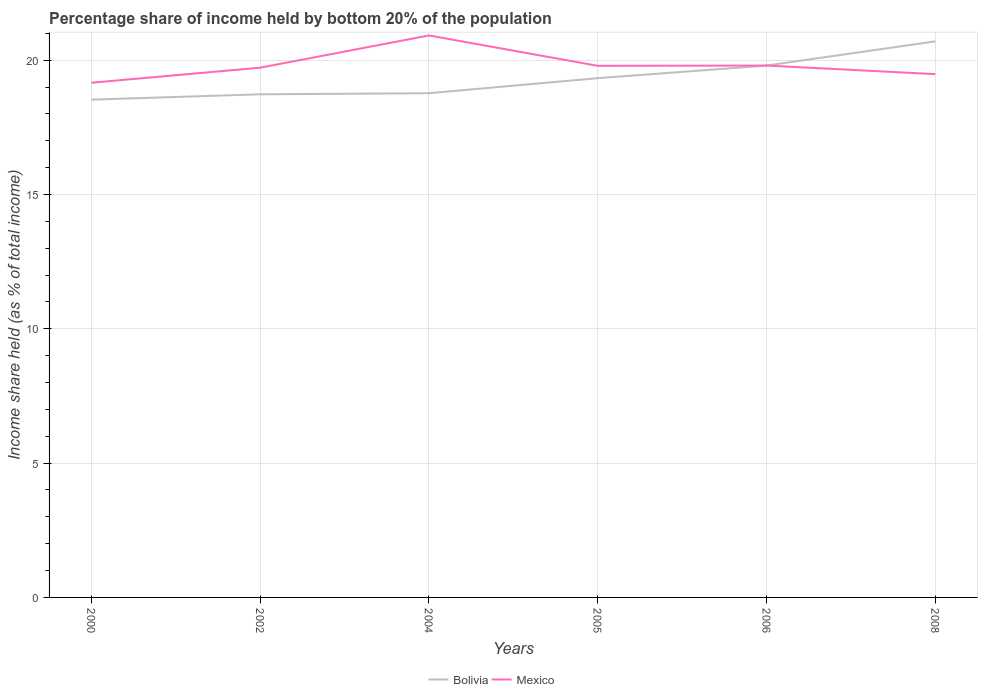Does the line corresponding to Mexico intersect with the line corresponding to Bolivia?
Ensure brevity in your answer.  Yes. Across all years, what is the maximum share of income held by bottom 20% of the population in Mexico?
Your response must be concise. 19.16. In which year was the share of income held by bottom 20% of the population in Bolivia maximum?
Your answer should be compact. 2000. What is the total share of income held by bottom 20% of the population in Mexico in the graph?
Give a very brief answer. -1.76. What is the difference between the highest and the second highest share of income held by bottom 20% of the population in Bolivia?
Offer a very short reply. 2.17. What is the difference between the highest and the lowest share of income held by bottom 20% of the population in Bolivia?
Provide a short and direct response. 3. How many years are there in the graph?
Make the answer very short. 6. What is the difference between two consecutive major ticks on the Y-axis?
Your answer should be very brief. 5. Does the graph contain any zero values?
Provide a succinct answer. No. How are the legend labels stacked?
Your answer should be very brief. Horizontal. What is the title of the graph?
Your answer should be compact. Percentage share of income held by bottom 20% of the population. What is the label or title of the X-axis?
Your answer should be very brief. Years. What is the label or title of the Y-axis?
Your answer should be very brief. Income share held (as % of total income). What is the Income share held (as % of total income) of Bolivia in 2000?
Make the answer very short. 18.53. What is the Income share held (as % of total income) of Mexico in 2000?
Give a very brief answer. 19.16. What is the Income share held (as % of total income) of Bolivia in 2002?
Provide a short and direct response. 18.73. What is the Income share held (as % of total income) in Mexico in 2002?
Ensure brevity in your answer.  19.72. What is the Income share held (as % of total income) of Bolivia in 2004?
Your answer should be very brief. 18.77. What is the Income share held (as % of total income) in Mexico in 2004?
Give a very brief answer. 20.92. What is the Income share held (as % of total income) in Bolivia in 2005?
Your answer should be very brief. 19.33. What is the Income share held (as % of total income) in Mexico in 2005?
Ensure brevity in your answer.  19.79. What is the Income share held (as % of total income) in Bolivia in 2006?
Your answer should be compact. 19.8. What is the Income share held (as % of total income) of Mexico in 2006?
Keep it short and to the point. 19.8. What is the Income share held (as % of total income) of Bolivia in 2008?
Provide a succinct answer. 20.7. What is the Income share held (as % of total income) in Mexico in 2008?
Your answer should be compact. 19.48. Across all years, what is the maximum Income share held (as % of total income) in Bolivia?
Offer a very short reply. 20.7. Across all years, what is the maximum Income share held (as % of total income) of Mexico?
Keep it short and to the point. 20.92. Across all years, what is the minimum Income share held (as % of total income) of Bolivia?
Provide a short and direct response. 18.53. Across all years, what is the minimum Income share held (as % of total income) of Mexico?
Your response must be concise. 19.16. What is the total Income share held (as % of total income) of Bolivia in the graph?
Provide a short and direct response. 115.86. What is the total Income share held (as % of total income) in Mexico in the graph?
Your answer should be compact. 118.87. What is the difference between the Income share held (as % of total income) in Mexico in 2000 and that in 2002?
Your answer should be compact. -0.56. What is the difference between the Income share held (as % of total income) in Bolivia in 2000 and that in 2004?
Provide a short and direct response. -0.24. What is the difference between the Income share held (as % of total income) of Mexico in 2000 and that in 2004?
Make the answer very short. -1.76. What is the difference between the Income share held (as % of total income) in Mexico in 2000 and that in 2005?
Offer a very short reply. -0.63. What is the difference between the Income share held (as % of total income) of Bolivia in 2000 and that in 2006?
Make the answer very short. -1.27. What is the difference between the Income share held (as % of total income) of Mexico in 2000 and that in 2006?
Ensure brevity in your answer.  -0.64. What is the difference between the Income share held (as % of total income) of Bolivia in 2000 and that in 2008?
Give a very brief answer. -2.17. What is the difference between the Income share held (as % of total income) in Mexico in 2000 and that in 2008?
Ensure brevity in your answer.  -0.32. What is the difference between the Income share held (as % of total income) in Bolivia in 2002 and that in 2004?
Offer a very short reply. -0.04. What is the difference between the Income share held (as % of total income) of Bolivia in 2002 and that in 2005?
Offer a terse response. -0.6. What is the difference between the Income share held (as % of total income) of Mexico in 2002 and that in 2005?
Your answer should be very brief. -0.07. What is the difference between the Income share held (as % of total income) in Bolivia in 2002 and that in 2006?
Make the answer very short. -1.07. What is the difference between the Income share held (as % of total income) in Mexico in 2002 and that in 2006?
Make the answer very short. -0.08. What is the difference between the Income share held (as % of total income) in Bolivia in 2002 and that in 2008?
Your answer should be very brief. -1.97. What is the difference between the Income share held (as % of total income) in Mexico in 2002 and that in 2008?
Offer a terse response. 0.24. What is the difference between the Income share held (as % of total income) of Bolivia in 2004 and that in 2005?
Your answer should be compact. -0.56. What is the difference between the Income share held (as % of total income) of Mexico in 2004 and that in 2005?
Provide a succinct answer. 1.13. What is the difference between the Income share held (as % of total income) of Bolivia in 2004 and that in 2006?
Provide a succinct answer. -1.03. What is the difference between the Income share held (as % of total income) in Mexico in 2004 and that in 2006?
Ensure brevity in your answer.  1.12. What is the difference between the Income share held (as % of total income) of Bolivia in 2004 and that in 2008?
Offer a very short reply. -1.93. What is the difference between the Income share held (as % of total income) in Mexico in 2004 and that in 2008?
Your answer should be very brief. 1.44. What is the difference between the Income share held (as % of total income) in Bolivia in 2005 and that in 2006?
Offer a terse response. -0.47. What is the difference between the Income share held (as % of total income) of Mexico in 2005 and that in 2006?
Keep it short and to the point. -0.01. What is the difference between the Income share held (as % of total income) in Bolivia in 2005 and that in 2008?
Provide a succinct answer. -1.37. What is the difference between the Income share held (as % of total income) in Mexico in 2005 and that in 2008?
Your answer should be very brief. 0.31. What is the difference between the Income share held (as % of total income) of Bolivia in 2006 and that in 2008?
Ensure brevity in your answer.  -0.9. What is the difference between the Income share held (as % of total income) in Mexico in 2006 and that in 2008?
Ensure brevity in your answer.  0.32. What is the difference between the Income share held (as % of total income) in Bolivia in 2000 and the Income share held (as % of total income) in Mexico in 2002?
Provide a succinct answer. -1.19. What is the difference between the Income share held (as % of total income) of Bolivia in 2000 and the Income share held (as % of total income) of Mexico in 2004?
Your answer should be compact. -2.39. What is the difference between the Income share held (as % of total income) of Bolivia in 2000 and the Income share held (as % of total income) of Mexico in 2005?
Provide a succinct answer. -1.26. What is the difference between the Income share held (as % of total income) in Bolivia in 2000 and the Income share held (as % of total income) in Mexico in 2006?
Offer a very short reply. -1.27. What is the difference between the Income share held (as % of total income) of Bolivia in 2000 and the Income share held (as % of total income) of Mexico in 2008?
Your response must be concise. -0.95. What is the difference between the Income share held (as % of total income) of Bolivia in 2002 and the Income share held (as % of total income) of Mexico in 2004?
Offer a terse response. -2.19. What is the difference between the Income share held (as % of total income) of Bolivia in 2002 and the Income share held (as % of total income) of Mexico in 2005?
Offer a very short reply. -1.06. What is the difference between the Income share held (as % of total income) of Bolivia in 2002 and the Income share held (as % of total income) of Mexico in 2006?
Make the answer very short. -1.07. What is the difference between the Income share held (as % of total income) of Bolivia in 2002 and the Income share held (as % of total income) of Mexico in 2008?
Ensure brevity in your answer.  -0.75. What is the difference between the Income share held (as % of total income) in Bolivia in 2004 and the Income share held (as % of total income) in Mexico in 2005?
Keep it short and to the point. -1.02. What is the difference between the Income share held (as % of total income) in Bolivia in 2004 and the Income share held (as % of total income) in Mexico in 2006?
Your answer should be very brief. -1.03. What is the difference between the Income share held (as % of total income) of Bolivia in 2004 and the Income share held (as % of total income) of Mexico in 2008?
Make the answer very short. -0.71. What is the difference between the Income share held (as % of total income) in Bolivia in 2005 and the Income share held (as % of total income) in Mexico in 2006?
Offer a terse response. -0.47. What is the difference between the Income share held (as % of total income) of Bolivia in 2005 and the Income share held (as % of total income) of Mexico in 2008?
Your response must be concise. -0.15. What is the difference between the Income share held (as % of total income) of Bolivia in 2006 and the Income share held (as % of total income) of Mexico in 2008?
Your answer should be very brief. 0.32. What is the average Income share held (as % of total income) in Bolivia per year?
Give a very brief answer. 19.31. What is the average Income share held (as % of total income) in Mexico per year?
Keep it short and to the point. 19.81. In the year 2000, what is the difference between the Income share held (as % of total income) of Bolivia and Income share held (as % of total income) of Mexico?
Keep it short and to the point. -0.63. In the year 2002, what is the difference between the Income share held (as % of total income) in Bolivia and Income share held (as % of total income) in Mexico?
Provide a short and direct response. -0.99. In the year 2004, what is the difference between the Income share held (as % of total income) of Bolivia and Income share held (as % of total income) of Mexico?
Offer a terse response. -2.15. In the year 2005, what is the difference between the Income share held (as % of total income) of Bolivia and Income share held (as % of total income) of Mexico?
Your answer should be compact. -0.46. In the year 2008, what is the difference between the Income share held (as % of total income) of Bolivia and Income share held (as % of total income) of Mexico?
Provide a short and direct response. 1.22. What is the ratio of the Income share held (as % of total income) of Bolivia in 2000 to that in 2002?
Your response must be concise. 0.99. What is the ratio of the Income share held (as % of total income) of Mexico in 2000 to that in 2002?
Your answer should be compact. 0.97. What is the ratio of the Income share held (as % of total income) in Bolivia in 2000 to that in 2004?
Provide a short and direct response. 0.99. What is the ratio of the Income share held (as % of total income) in Mexico in 2000 to that in 2004?
Your answer should be very brief. 0.92. What is the ratio of the Income share held (as % of total income) in Bolivia in 2000 to that in 2005?
Your answer should be very brief. 0.96. What is the ratio of the Income share held (as % of total income) of Mexico in 2000 to that in 2005?
Offer a very short reply. 0.97. What is the ratio of the Income share held (as % of total income) in Bolivia in 2000 to that in 2006?
Your answer should be compact. 0.94. What is the ratio of the Income share held (as % of total income) in Bolivia in 2000 to that in 2008?
Provide a succinct answer. 0.9. What is the ratio of the Income share held (as % of total income) of Mexico in 2000 to that in 2008?
Your answer should be very brief. 0.98. What is the ratio of the Income share held (as % of total income) of Mexico in 2002 to that in 2004?
Your answer should be very brief. 0.94. What is the ratio of the Income share held (as % of total income) in Bolivia in 2002 to that in 2005?
Provide a succinct answer. 0.97. What is the ratio of the Income share held (as % of total income) of Bolivia in 2002 to that in 2006?
Offer a terse response. 0.95. What is the ratio of the Income share held (as % of total income) of Bolivia in 2002 to that in 2008?
Your response must be concise. 0.9. What is the ratio of the Income share held (as % of total income) in Mexico in 2002 to that in 2008?
Provide a short and direct response. 1.01. What is the ratio of the Income share held (as % of total income) in Mexico in 2004 to that in 2005?
Offer a terse response. 1.06. What is the ratio of the Income share held (as % of total income) in Bolivia in 2004 to that in 2006?
Your response must be concise. 0.95. What is the ratio of the Income share held (as % of total income) of Mexico in 2004 to that in 2006?
Provide a succinct answer. 1.06. What is the ratio of the Income share held (as % of total income) in Bolivia in 2004 to that in 2008?
Provide a short and direct response. 0.91. What is the ratio of the Income share held (as % of total income) in Mexico in 2004 to that in 2008?
Provide a short and direct response. 1.07. What is the ratio of the Income share held (as % of total income) in Bolivia in 2005 to that in 2006?
Provide a succinct answer. 0.98. What is the ratio of the Income share held (as % of total income) in Bolivia in 2005 to that in 2008?
Offer a terse response. 0.93. What is the ratio of the Income share held (as % of total income) in Mexico in 2005 to that in 2008?
Your response must be concise. 1.02. What is the ratio of the Income share held (as % of total income) of Bolivia in 2006 to that in 2008?
Ensure brevity in your answer.  0.96. What is the ratio of the Income share held (as % of total income) in Mexico in 2006 to that in 2008?
Your answer should be very brief. 1.02. What is the difference between the highest and the second highest Income share held (as % of total income) in Bolivia?
Provide a short and direct response. 0.9. What is the difference between the highest and the second highest Income share held (as % of total income) in Mexico?
Your answer should be compact. 1.12. What is the difference between the highest and the lowest Income share held (as % of total income) of Bolivia?
Keep it short and to the point. 2.17. What is the difference between the highest and the lowest Income share held (as % of total income) in Mexico?
Your answer should be very brief. 1.76. 